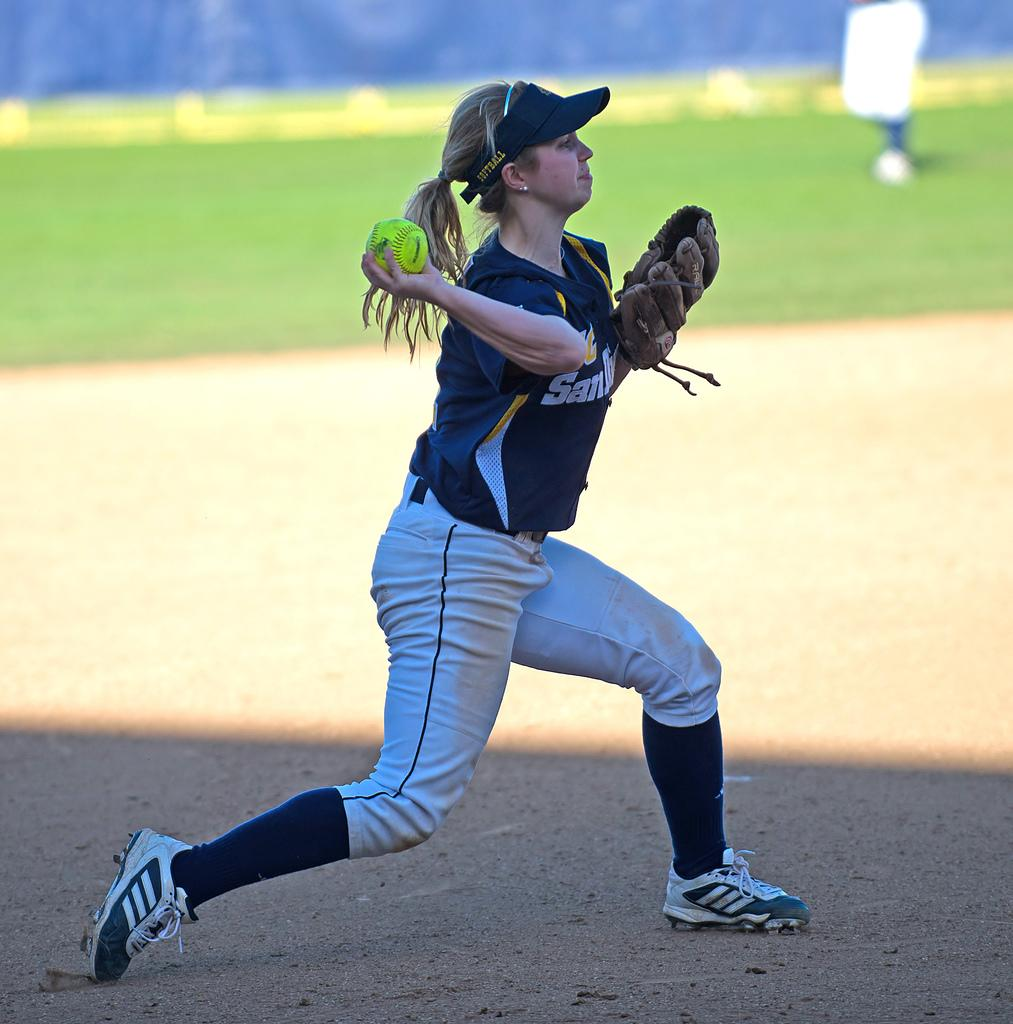Provide a one-sentence caption for the provided image. A girl with a San Diego baseball team throws a ball. 